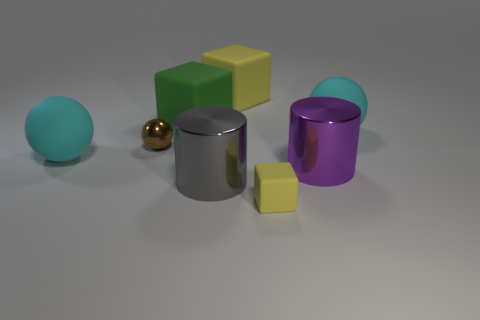How big is the purple cylinder?
Your response must be concise. Large. Is the number of big gray things that are in front of the small brown metal thing greater than the number of green objects that are in front of the purple shiny cylinder?
Provide a succinct answer. Yes. What is the material of the tiny cube?
Your answer should be very brief. Rubber. What is the shape of the big cyan matte object behind the big cyan rubber ball on the left side of the large matte block that is behind the green rubber object?
Offer a very short reply. Sphere. How many other things are made of the same material as the big gray cylinder?
Keep it short and to the point. 2. Do the large cyan ball left of the small yellow block and the big yellow cube that is behind the tiny block have the same material?
Your answer should be very brief. Yes. How many big cyan matte balls are on the left side of the green rubber cube and on the right side of the tiny yellow matte block?
Your answer should be compact. 0. Is there a purple matte thing of the same shape as the large green matte object?
Ensure brevity in your answer.  No. What shape is the other rubber thing that is the same size as the brown object?
Provide a short and direct response. Cube. Is the number of purple metal cylinders left of the tiny matte block the same as the number of purple shiny cylinders behind the big purple cylinder?
Provide a short and direct response. Yes. 